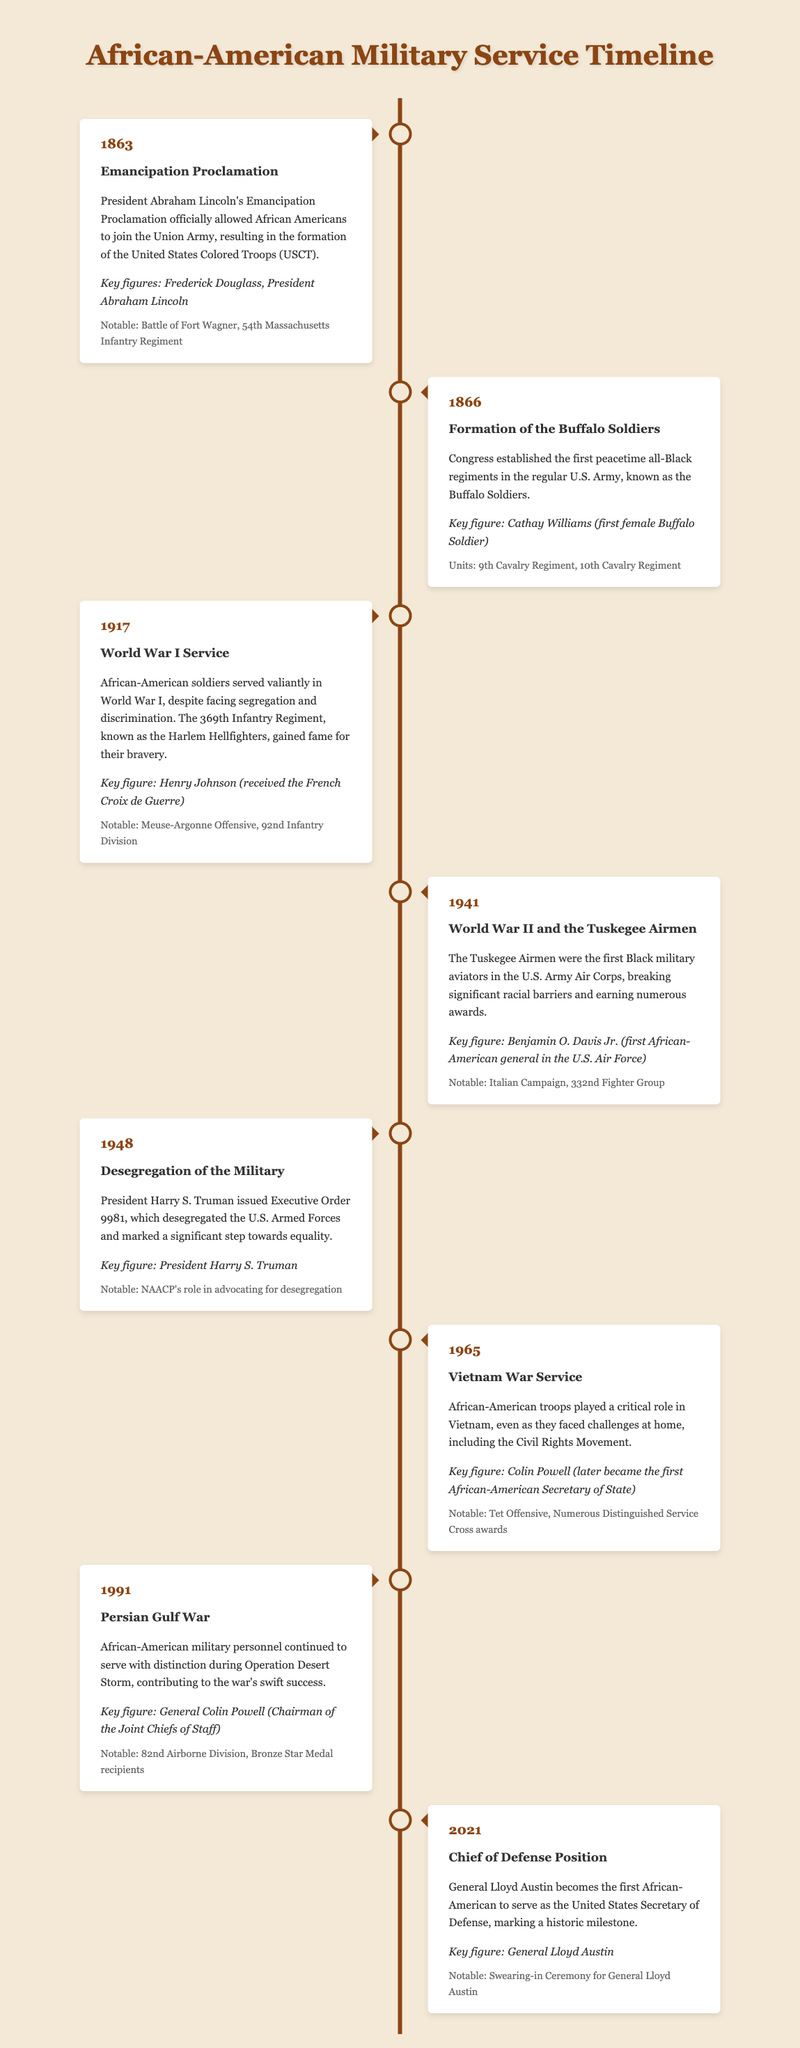What year was the Emancipation Proclamation issued? The event mentions the year 1863 as the time when President Abraham Lincoln's Emancipation Proclamation was issued.
Answer: 1863 Who was the first female Buffalo Soldier? The document identifies Cathay Williams as the first female Buffalo Soldier in the formation of the Buffalo Soldiers in 1866.
Answer: Cathay Williams What significant military unit is associated with the Harlem Hellfighters? The context indicates that the 369th Infantry Regiment is known as the Harlem Hellfighters, famous for their bravery during World War I.
Answer: 369th Infantry Regiment Which executive order desegregated the U.S. Armed Forces? The document states that President Harry S. Truman issued Executive Order 9981 to desegregate the military in 1948.
Answer: Executive Order 9981 What was the notable campaign involving the Tuskegee Airmen? The timeline includes reference to the Italian Campaign as a significant operation involving the Tuskegee Airmen during World War II.
Answer: Italian Campaign Who became the first African-American Secretary of Defense? The document notes that General Lloyd Austin became the first African-American Secretary of Defense in 2021.
Answer: General Lloyd Austin In what year did African-Americans play a critical role in the Vietnam War? The timeline highlights the year 1965 as the period when African-American troops were crucial in Vietnam.
Answer: 1965 What notable role did Colin Powell have in the Persian Gulf War? The document references Colin Powell as the Chairman of the Joint Chiefs of Staff during the Persian Gulf War in 1991.
Answer: Chairman of the Joint Chiefs of Staff How many years passed between the Emancipation Proclamation and the formation of the Buffalo Soldiers? The timeline states the Emancipation Proclamation was in 1863 and the Buffalo Soldiers were formed in 1866, indicating a span of 3 years.
Answer: 3 years 